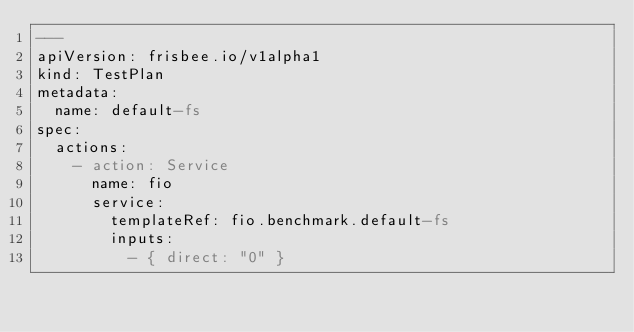Convert code to text. <code><loc_0><loc_0><loc_500><loc_500><_YAML_>---
apiVersion: frisbee.io/v1alpha1
kind: TestPlan
metadata:
  name: default-fs
spec:
  actions:
    - action: Service
      name: fio
      service:
        templateRef: fio.benchmark.default-fs
        inputs:
          - { direct: "0" }</code> 